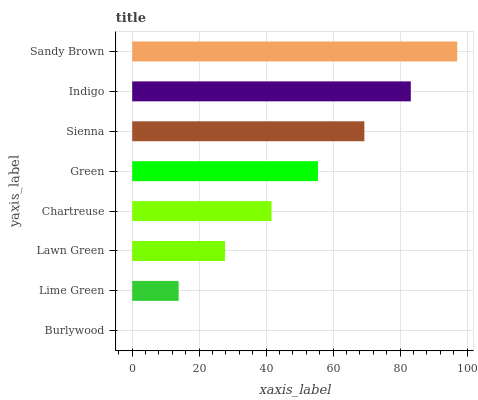Is Burlywood the minimum?
Answer yes or no. Yes. Is Sandy Brown the maximum?
Answer yes or no. Yes. Is Lime Green the minimum?
Answer yes or no. No. Is Lime Green the maximum?
Answer yes or no. No. Is Lime Green greater than Burlywood?
Answer yes or no. Yes. Is Burlywood less than Lime Green?
Answer yes or no. Yes. Is Burlywood greater than Lime Green?
Answer yes or no. No. Is Lime Green less than Burlywood?
Answer yes or no. No. Is Green the high median?
Answer yes or no. Yes. Is Chartreuse the low median?
Answer yes or no. Yes. Is Sandy Brown the high median?
Answer yes or no. No. Is Indigo the low median?
Answer yes or no. No. 